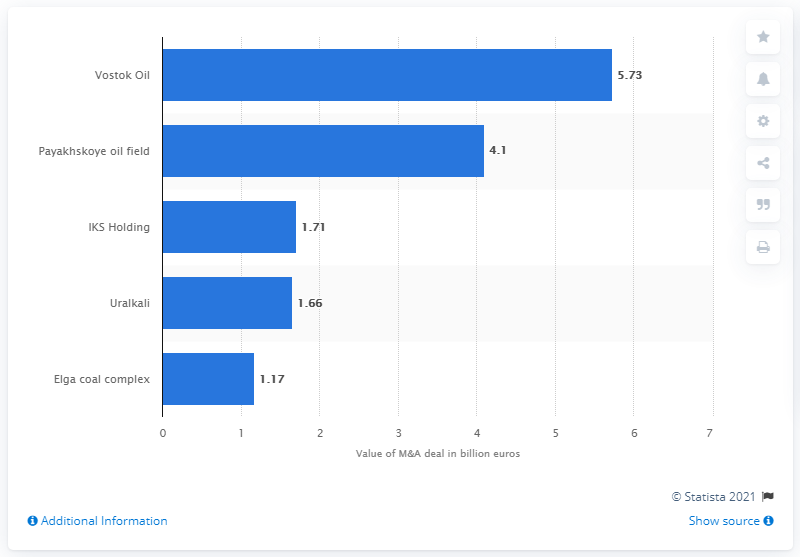Outline some significant characteristics in this image. The second largest M&A deal in Russia in 2020 was valued at 4.1... The deal was valued at approximately $5.73 million in 2020. 